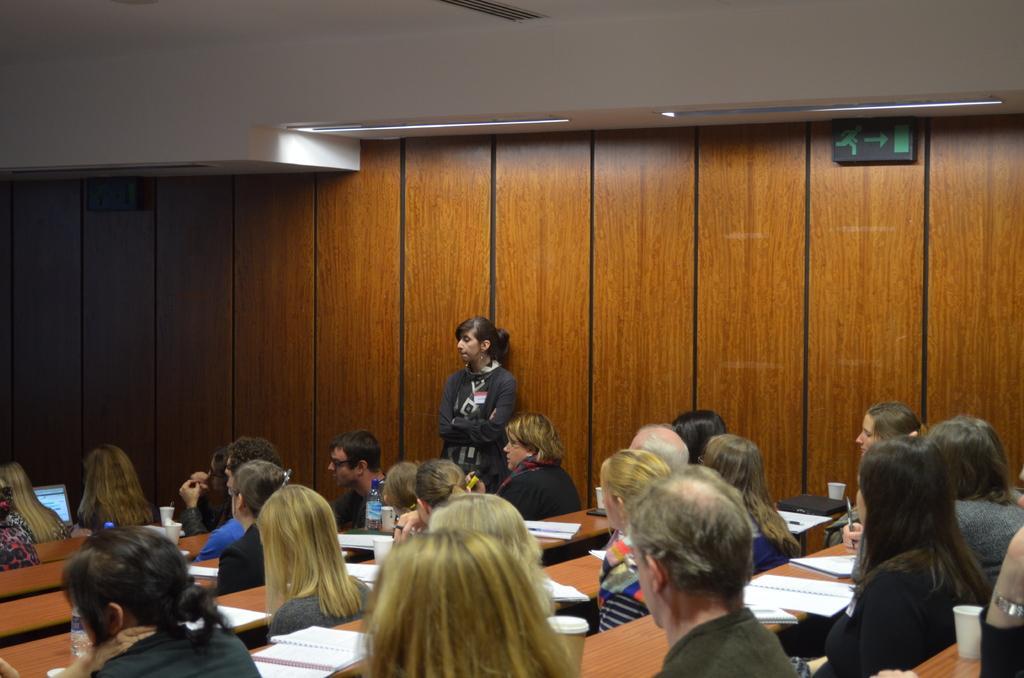Could you give a brief overview of what you see in this image? In this image there are people sitting on the chairs. In front of them there are tables. On top of it there are books, cups, bottles and a laptop. In the background of the image there are sign boards on the wall. In front of the wall there is a person standing. On top of the image there are lights. 